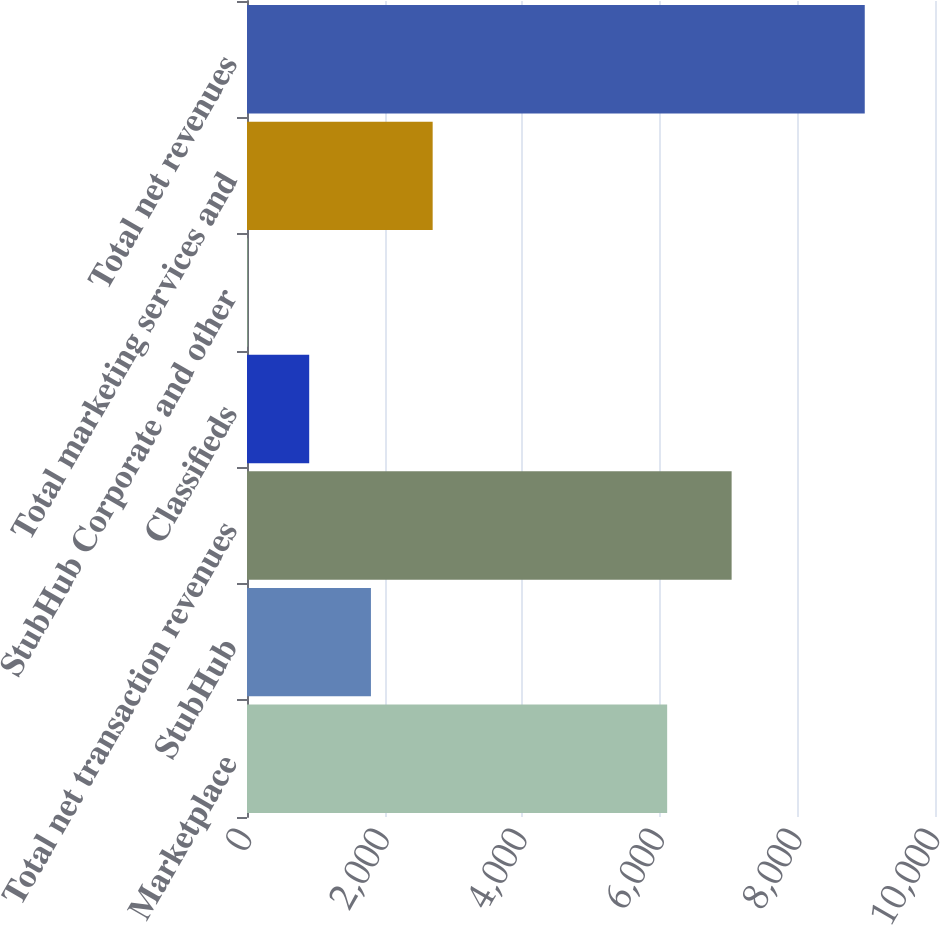Convert chart. <chart><loc_0><loc_0><loc_500><loc_500><bar_chart><fcel>Marketplace<fcel>StubHub<fcel>Total net transaction revenues<fcel>Classifieds<fcel>StubHub Corporate and other<fcel>Total marketing services and<fcel>Total net revenues<nl><fcel>6107<fcel>1801.4<fcel>7044<fcel>904.2<fcel>7<fcel>2698.6<fcel>8979<nl></chart> 